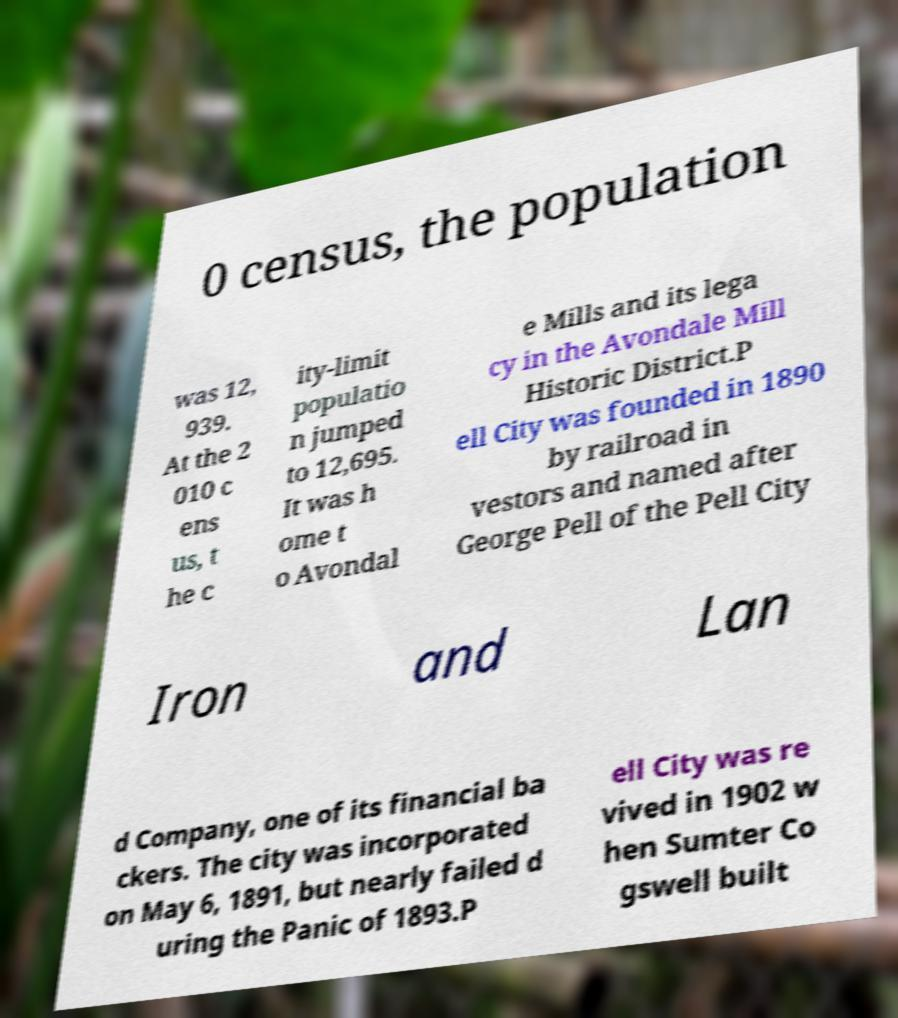What messages or text are displayed in this image? I need them in a readable, typed format. 0 census, the population was 12, 939. At the 2 010 c ens us, t he c ity-limit populatio n jumped to 12,695. It was h ome t o Avondal e Mills and its lega cy in the Avondale Mill Historic District.P ell City was founded in 1890 by railroad in vestors and named after George Pell of the Pell City Iron and Lan d Company, one of its financial ba ckers. The city was incorporated on May 6, 1891, but nearly failed d uring the Panic of 1893.P ell City was re vived in 1902 w hen Sumter Co gswell built 